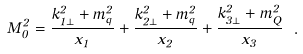Convert formula to latex. <formula><loc_0><loc_0><loc_500><loc_500>M _ { 0 } ^ { 2 } = \frac { k ^ { 2 } _ { 1 \perp } + m _ { q } ^ { 2 } } { x _ { 1 } } + \frac { k ^ { 2 } _ { 2 \perp } + m _ { q } ^ { 2 } } { x _ { 2 } } + \frac { k ^ { 2 } _ { 3 \perp } + m _ { Q } ^ { 2 } } { x _ { 3 } } \ .</formula> 